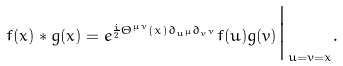Convert formula to latex. <formula><loc_0><loc_0><loc_500><loc_500>f ( x ) * g ( x ) = e ^ { \frac { i } { 2 } \Theta ^ { \mu \nu } ( x ) \partial _ { u ^ { \mu } } \partial _ { v ^ { \nu } } } f ( u ) g ( v ) \Big | _ { u = v = x } .</formula> 